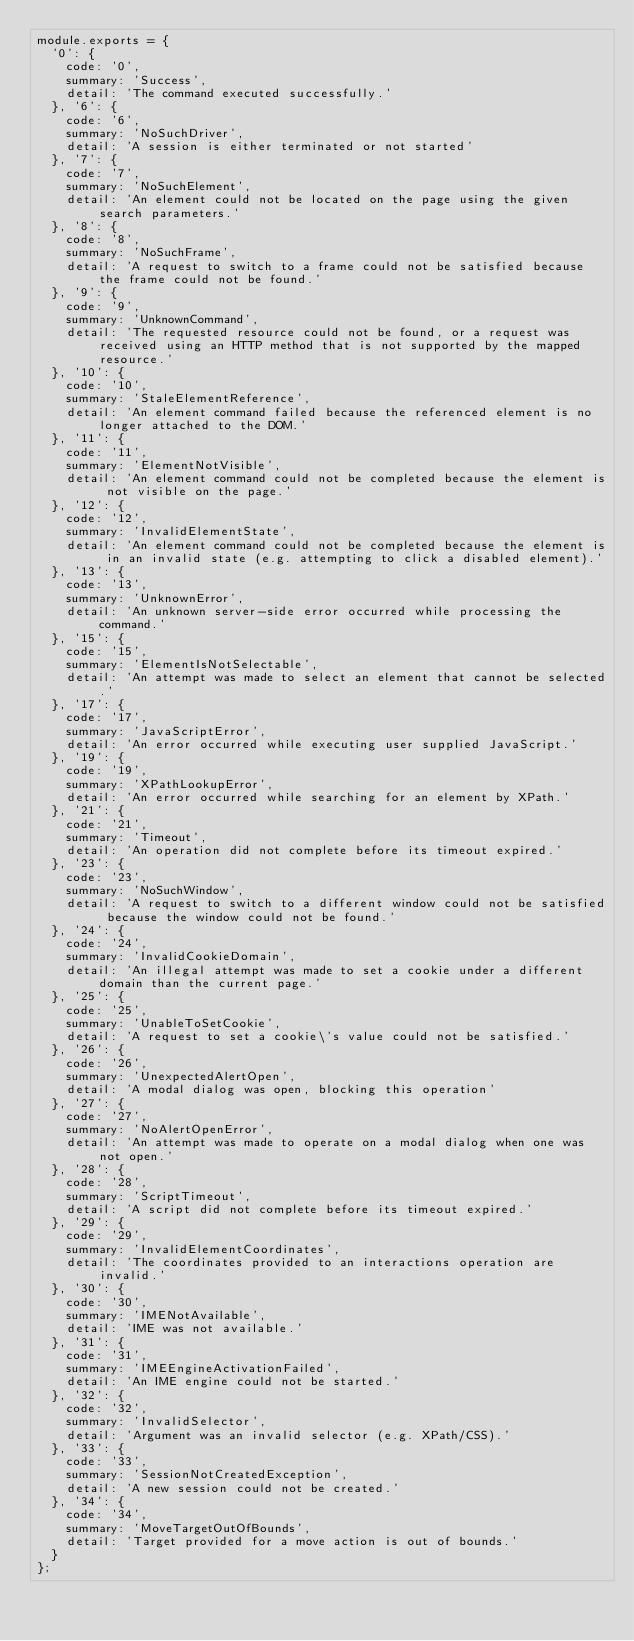<code> <loc_0><loc_0><loc_500><loc_500><_JavaScript_>module.exports = {
  '0': {
    code: '0',
    summary: 'Success',
    detail: 'The command executed successfully.'
  }, '6': {
    code: '6',
    summary: 'NoSuchDriver',
    detail: 'A session is either terminated or not started'
  }, '7': {
    code: '7',
    summary: 'NoSuchElement',
    detail: 'An element could not be located on the page using the given search parameters.'
  }, '8': {
    code: '8',
    summary: 'NoSuchFrame',
    detail: 'A request to switch to a frame could not be satisfied because the frame could not be found.'
  }, '9': {
    code: '9',
    summary: 'UnknownCommand',
    detail: 'The requested resource could not be found, or a request was received using an HTTP method that is not supported by the mapped resource.'
  }, '10': {
    code: '10',
    summary: 'StaleElementReference',
    detail: 'An element command failed because the referenced element is no longer attached to the DOM.'
  }, '11': {
    code: '11',
    summary: 'ElementNotVisible',
    detail: 'An element command could not be completed because the element is not visible on the page.'
  }, '12': {
    code: '12',
    summary: 'InvalidElementState',
    detail: 'An element command could not be completed because the element is in an invalid state (e.g. attempting to click a disabled element).'
  }, '13': {
    code: '13',
    summary: 'UnknownError',
    detail: 'An unknown server-side error occurred while processing the command.'
  }, '15': {
    code: '15',
    summary: 'ElementIsNotSelectable',
    detail: 'An attempt was made to select an element that cannot be selected.'
  }, '17': {
    code: '17',
    summary: 'JavaScriptError',
    detail: 'An error occurred while executing user supplied JavaScript.'
  }, '19': {
    code: '19',
    summary: 'XPathLookupError',
    detail: 'An error occurred while searching for an element by XPath.'
  }, '21': {
    code: '21',
    summary: 'Timeout',
    detail: 'An operation did not complete before its timeout expired.'
  }, '23': {
    code: '23',
    summary: 'NoSuchWindow',
    detail: 'A request to switch to a different window could not be satisfied because the window could not be found.'
  }, '24': {
    code: '24',
    summary: 'InvalidCookieDomain',
    detail: 'An illegal attempt was made to set a cookie under a different domain than the current page.'
  }, '25': {
    code: '25',
    summary: 'UnableToSetCookie',
    detail: 'A request to set a cookie\'s value could not be satisfied.'
  }, '26': {
    code: '26',
    summary: 'UnexpectedAlertOpen',
    detail: 'A modal dialog was open, blocking this operation'
  }, '27': {
    code: '27',
    summary: 'NoAlertOpenError',
    detail: 'An attempt was made to operate on a modal dialog when one was not open.'
  }, '28': {
    code: '28',
    summary: 'ScriptTimeout',
    detail: 'A script did not complete before its timeout expired.'
  }, '29': {
    code: '29',
    summary: 'InvalidElementCoordinates',
    detail: 'The coordinates provided to an interactions operation are invalid.'
  }, '30': {
    code: '30',
    summary: 'IMENotAvailable',
    detail: 'IME was not available.'
  }, '31': {
    code: '31',
    summary: 'IMEEngineActivationFailed',
    detail: 'An IME engine could not be started.'
  }, '32': {
    code: '32',
    summary: 'InvalidSelector',
    detail: 'Argument was an invalid selector (e.g. XPath/CSS).'
  }, '33': {
    code: '33',
    summary: 'SessionNotCreatedException',
    detail: 'A new session could not be created.'
  }, '34': {
    code: '34',
    summary: 'MoveTargetOutOfBounds',
    detail: 'Target provided for a move action is out of bounds.'
  }
};</code> 